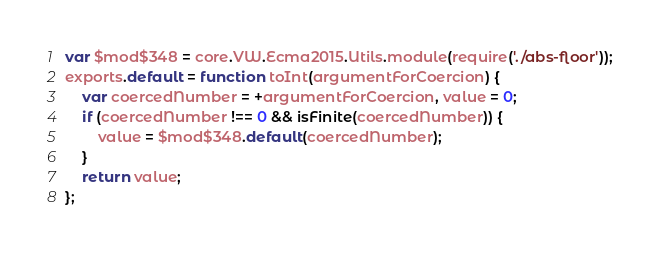<code> <loc_0><loc_0><loc_500><loc_500><_JavaScript_>var $mod$348 = core.VW.Ecma2015.Utils.module(require('./abs-floor'));
exports.default = function toInt(argumentForCoercion) {
    var coercedNumber = +argumentForCoercion, value = 0;
    if (coercedNumber !== 0 && isFinite(coercedNumber)) {
        value = $mod$348.default(coercedNumber);
    }
    return value;
};</code> 